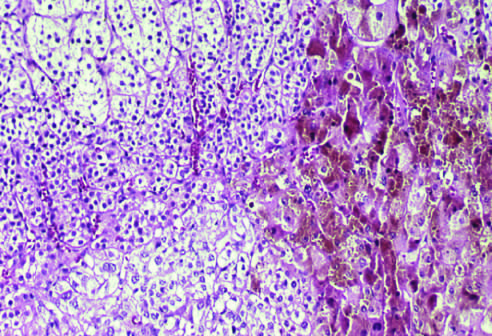what are the nodules composed of?
Answer the question using a single word or phrase. Cells containing lipofuscin pigment 